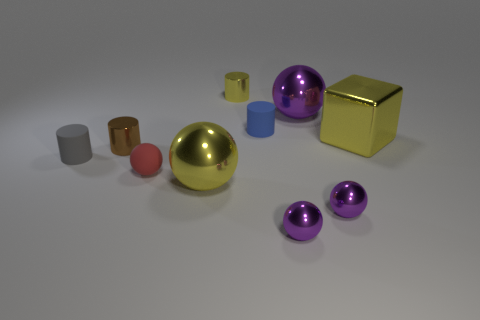Are the spheres meant to represent any particular material? The spheres have a reflective surface, suggesting they might be made of a polished metal or a similarly reflective material. 